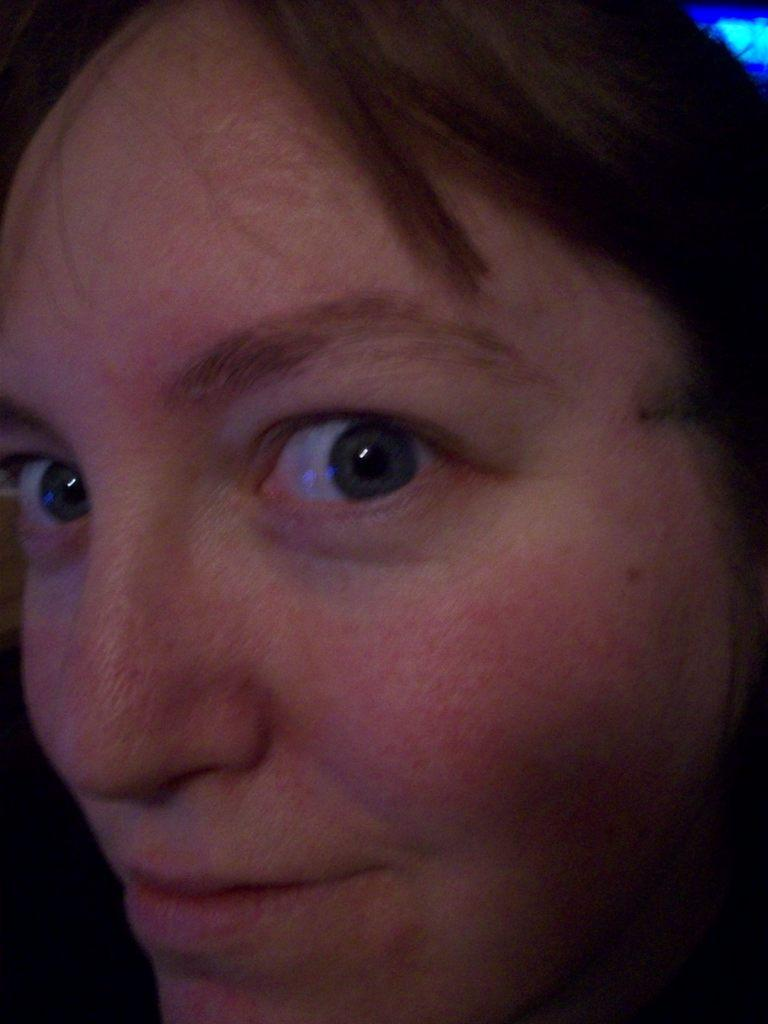What is the main subject of the image? There is a person in the image. Can you see a nest in the image? There is no nest present in the image. Is the person in the image kicking a cow? There is no cow or indication of kicking in the image. 